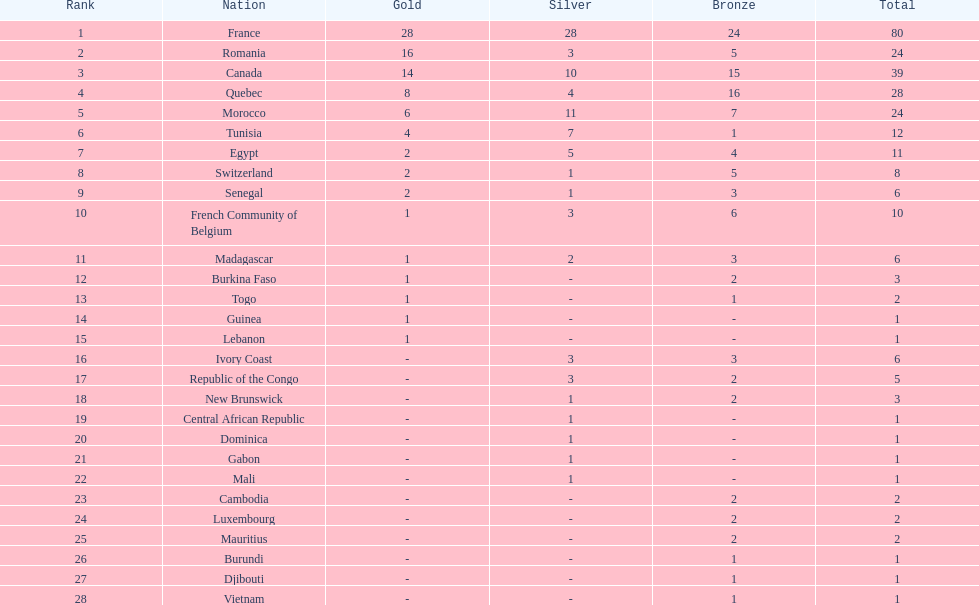What is the difference in the number of medals won by egypt compared to ivory coast? 5. 